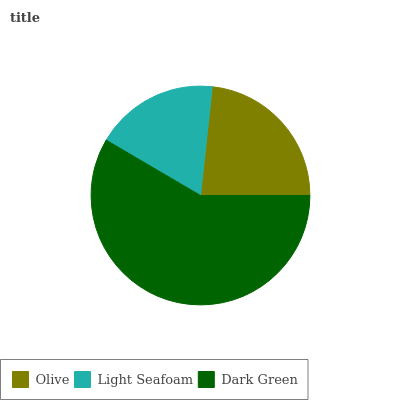Is Light Seafoam the minimum?
Answer yes or no. Yes. Is Dark Green the maximum?
Answer yes or no. Yes. Is Dark Green the minimum?
Answer yes or no. No. Is Light Seafoam the maximum?
Answer yes or no. No. Is Dark Green greater than Light Seafoam?
Answer yes or no. Yes. Is Light Seafoam less than Dark Green?
Answer yes or no. Yes. Is Light Seafoam greater than Dark Green?
Answer yes or no. No. Is Dark Green less than Light Seafoam?
Answer yes or no. No. Is Olive the high median?
Answer yes or no. Yes. Is Olive the low median?
Answer yes or no. Yes. Is Light Seafoam the high median?
Answer yes or no. No. Is Dark Green the low median?
Answer yes or no. No. 